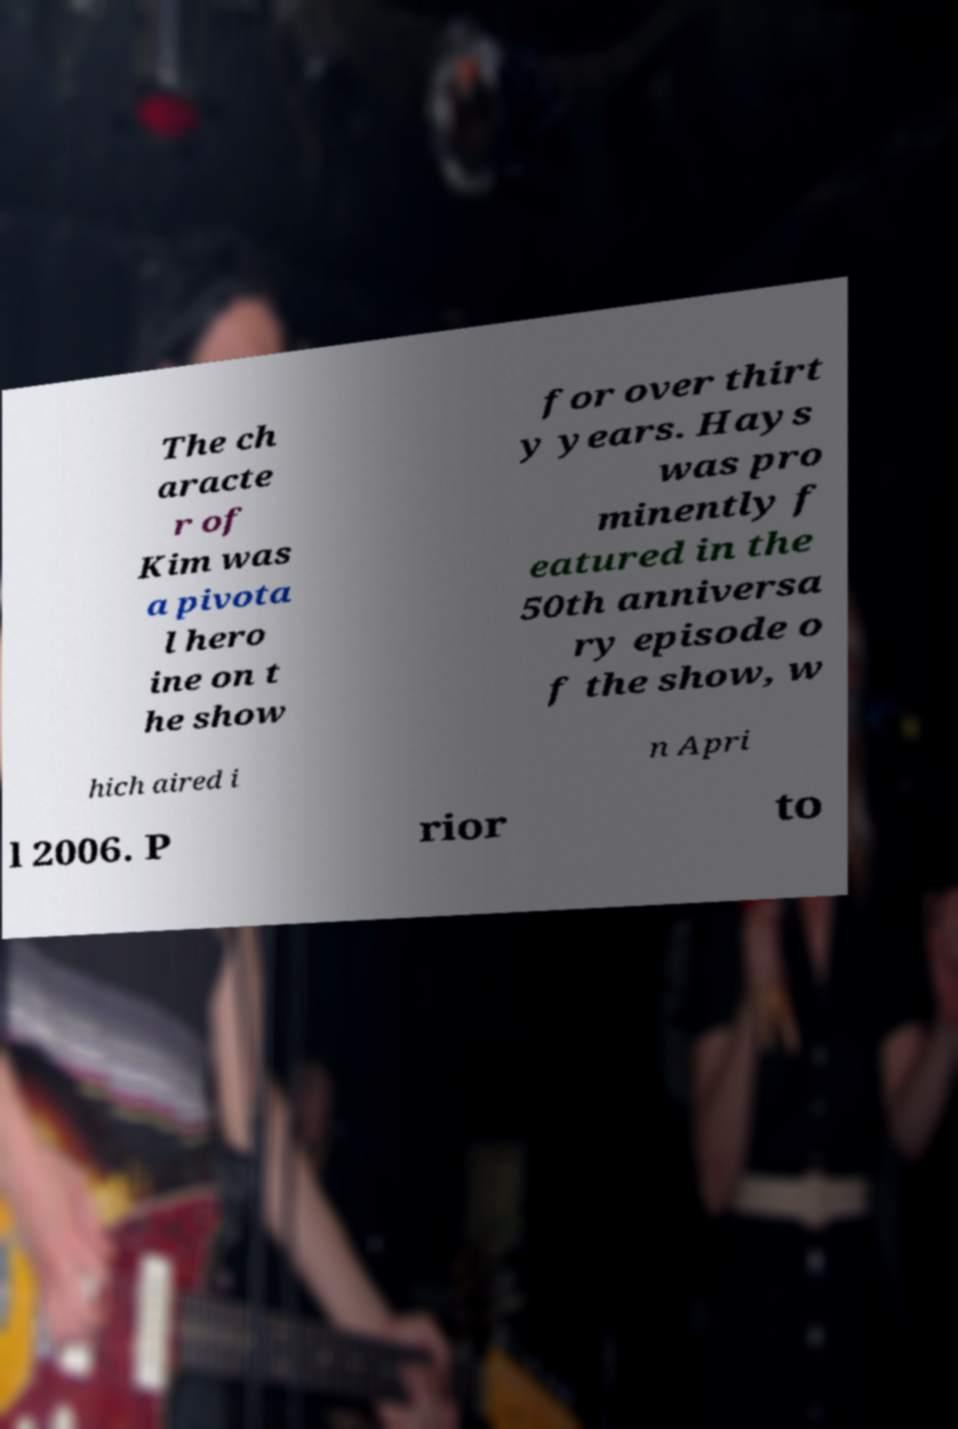Can you read and provide the text displayed in the image?This photo seems to have some interesting text. Can you extract and type it out for me? The ch aracte r of Kim was a pivota l hero ine on t he show for over thirt y years. Hays was pro minently f eatured in the 50th anniversa ry episode o f the show, w hich aired i n Apri l 2006. P rior to 